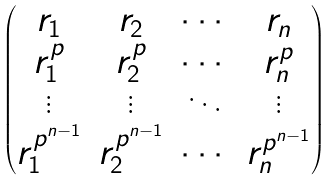<formula> <loc_0><loc_0><loc_500><loc_500>\begin{pmatrix} r _ { 1 } & r _ { 2 } & \cdots & r _ { n } \\ r _ { 1 } ^ { p } & r _ { 2 } ^ { p } & \cdots & r _ { n } ^ { p } \\ \vdots & \vdots & \ddots & \vdots \\ r _ { 1 } ^ { p ^ { n - 1 } } & r _ { 2 } ^ { p ^ { n - 1 } } & \cdots & r _ { n } ^ { p ^ { n - 1 } } \end{pmatrix}</formula> 